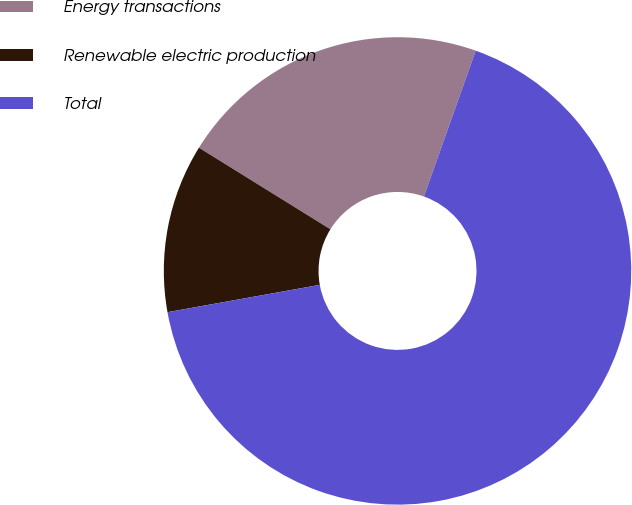<chart> <loc_0><loc_0><loc_500><loc_500><pie_chart><fcel>Energy transactions<fcel>Renewable electric production<fcel>Total<nl><fcel>21.59%<fcel>11.66%<fcel>66.74%<nl></chart> 